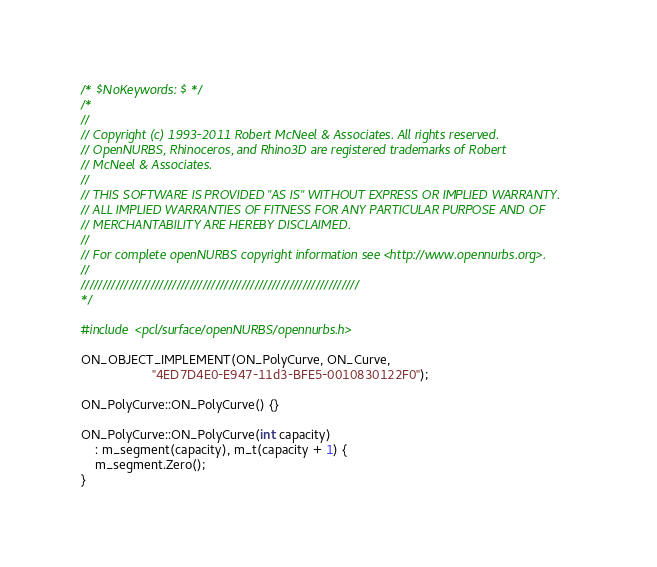Convert code to text. <code><loc_0><loc_0><loc_500><loc_500><_C++_>/* $NoKeywords: $ */
/*
//
// Copyright (c) 1993-2011 Robert McNeel & Associates. All rights reserved.
// OpenNURBS, Rhinoceros, and Rhino3D are registered trademarks of Robert
// McNeel & Associates.
//
// THIS SOFTWARE IS PROVIDED "AS IS" WITHOUT EXPRESS OR IMPLIED WARRANTY.
// ALL IMPLIED WARRANTIES OF FITNESS FOR ANY PARTICULAR PURPOSE AND OF
// MERCHANTABILITY ARE HEREBY DISCLAIMED.
//
// For complete openNURBS copyright information see <http://www.opennurbs.org>.
//
////////////////////////////////////////////////////////////////
*/

#include <pcl/surface/openNURBS/opennurbs.h>

ON_OBJECT_IMPLEMENT(ON_PolyCurve, ON_Curve,
                    "4ED7D4E0-E947-11d3-BFE5-0010830122F0");

ON_PolyCurve::ON_PolyCurve() {}

ON_PolyCurve::ON_PolyCurve(int capacity)
    : m_segment(capacity), m_t(capacity + 1) {
    m_segment.Zero();
}
</code> 